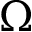Convert formula to latex. <formula><loc_0><loc_0><loc_500><loc_500>\Omega</formula> 